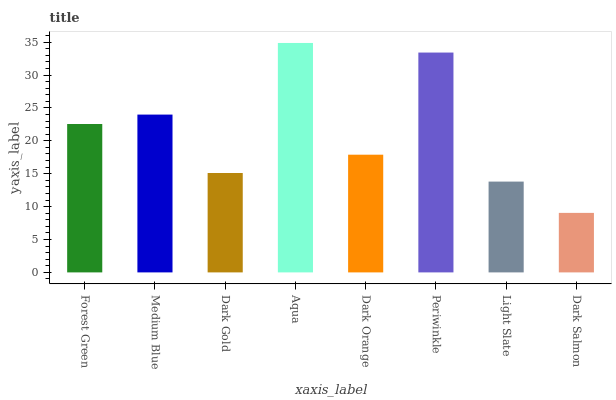Is Dark Salmon the minimum?
Answer yes or no. Yes. Is Aqua the maximum?
Answer yes or no. Yes. Is Medium Blue the minimum?
Answer yes or no. No. Is Medium Blue the maximum?
Answer yes or no. No. Is Medium Blue greater than Forest Green?
Answer yes or no. Yes. Is Forest Green less than Medium Blue?
Answer yes or no. Yes. Is Forest Green greater than Medium Blue?
Answer yes or no. No. Is Medium Blue less than Forest Green?
Answer yes or no. No. Is Forest Green the high median?
Answer yes or no. Yes. Is Dark Orange the low median?
Answer yes or no. Yes. Is Dark Salmon the high median?
Answer yes or no. No. Is Light Slate the low median?
Answer yes or no. No. 